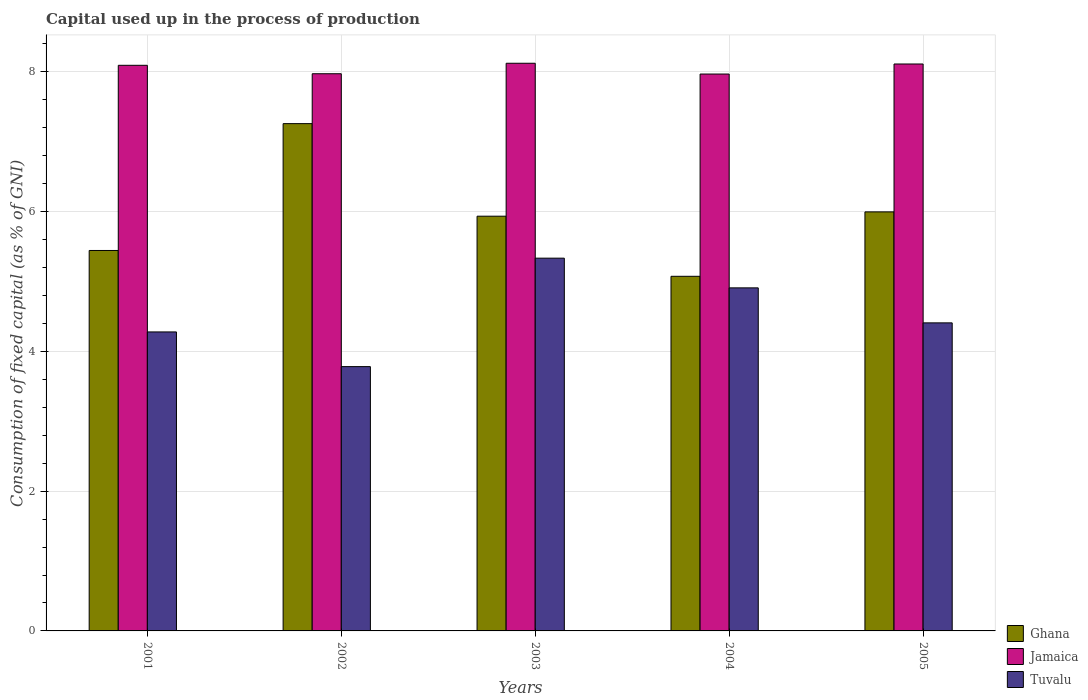How many different coloured bars are there?
Your answer should be compact. 3. Are the number of bars on each tick of the X-axis equal?
Your answer should be very brief. Yes. How many bars are there on the 1st tick from the right?
Provide a succinct answer. 3. What is the label of the 4th group of bars from the left?
Offer a very short reply. 2004. In how many cases, is the number of bars for a given year not equal to the number of legend labels?
Keep it short and to the point. 0. What is the capital used up in the process of production in Jamaica in 2001?
Make the answer very short. 8.09. Across all years, what is the maximum capital used up in the process of production in Tuvalu?
Make the answer very short. 5.33. Across all years, what is the minimum capital used up in the process of production in Tuvalu?
Your answer should be very brief. 3.78. In which year was the capital used up in the process of production in Jamaica maximum?
Provide a succinct answer. 2003. In which year was the capital used up in the process of production in Tuvalu minimum?
Offer a very short reply. 2002. What is the total capital used up in the process of production in Jamaica in the graph?
Your response must be concise. 40.27. What is the difference between the capital used up in the process of production in Ghana in 2001 and that in 2005?
Provide a short and direct response. -0.55. What is the difference between the capital used up in the process of production in Jamaica in 2002 and the capital used up in the process of production in Ghana in 2004?
Ensure brevity in your answer.  2.9. What is the average capital used up in the process of production in Jamaica per year?
Your answer should be compact. 8.05. In the year 2003, what is the difference between the capital used up in the process of production in Ghana and capital used up in the process of production in Tuvalu?
Provide a short and direct response. 0.6. In how many years, is the capital used up in the process of production in Ghana greater than 2 %?
Keep it short and to the point. 5. What is the ratio of the capital used up in the process of production in Ghana in 2002 to that in 2004?
Ensure brevity in your answer.  1.43. Is the capital used up in the process of production in Tuvalu in 2002 less than that in 2005?
Offer a very short reply. Yes. What is the difference between the highest and the second highest capital used up in the process of production in Tuvalu?
Your answer should be very brief. 0.43. What is the difference between the highest and the lowest capital used up in the process of production in Tuvalu?
Give a very brief answer. 1.55. In how many years, is the capital used up in the process of production in Tuvalu greater than the average capital used up in the process of production in Tuvalu taken over all years?
Provide a succinct answer. 2. What does the 3rd bar from the left in 2002 represents?
Your answer should be very brief. Tuvalu. What does the 2nd bar from the right in 2002 represents?
Provide a short and direct response. Jamaica. Is it the case that in every year, the sum of the capital used up in the process of production in Jamaica and capital used up in the process of production in Ghana is greater than the capital used up in the process of production in Tuvalu?
Your response must be concise. Yes. How many bars are there?
Offer a very short reply. 15. Are all the bars in the graph horizontal?
Your answer should be very brief. No. How many years are there in the graph?
Provide a succinct answer. 5. Does the graph contain any zero values?
Provide a short and direct response. No. Where does the legend appear in the graph?
Your answer should be very brief. Bottom right. How are the legend labels stacked?
Give a very brief answer. Vertical. What is the title of the graph?
Keep it short and to the point. Capital used up in the process of production. Does "Georgia" appear as one of the legend labels in the graph?
Make the answer very short. No. What is the label or title of the Y-axis?
Offer a terse response. Consumption of fixed capital (as % of GNI). What is the Consumption of fixed capital (as % of GNI) in Ghana in 2001?
Your answer should be compact. 5.44. What is the Consumption of fixed capital (as % of GNI) of Jamaica in 2001?
Give a very brief answer. 8.09. What is the Consumption of fixed capital (as % of GNI) of Tuvalu in 2001?
Offer a terse response. 4.28. What is the Consumption of fixed capital (as % of GNI) in Ghana in 2002?
Your response must be concise. 7.26. What is the Consumption of fixed capital (as % of GNI) of Jamaica in 2002?
Make the answer very short. 7.97. What is the Consumption of fixed capital (as % of GNI) in Tuvalu in 2002?
Provide a short and direct response. 3.78. What is the Consumption of fixed capital (as % of GNI) of Ghana in 2003?
Provide a short and direct response. 5.94. What is the Consumption of fixed capital (as % of GNI) in Jamaica in 2003?
Give a very brief answer. 8.12. What is the Consumption of fixed capital (as % of GNI) in Tuvalu in 2003?
Your response must be concise. 5.33. What is the Consumption of fixed capital (as % of GNI) of Ghana in 2004?
Provide a succinct answer. 5.07. What is the Consumption of fixed capital (as % of GNI) in Jamaica in 2004?
Keep it short and to the point. 7.97. What is the Consumption of fixed capital (as % of GNI) of Tuvalu in 2004?
Provide a short and direct response. 4.91. What is the Consumption of fixed capital (as % of GNI) in Ghana in 2005?
Provide a succinct answer. 6. What is the Consumption of fixed capital (as % of GNI) in Jamaica in 2005?
Make the answer very short. 8.11. What is the Consumption of fixed capital (as % of GNI) in Tuvalu in 2005?
Your answer should be very brief. 4.41. Across all years, what is the maximum Consumption of fixed capital (as % of GNI) in Ghana?
Your answer should be compact. 7.26. Across all years, what is the maximum Consumption of fixed capital (as % of GNI) in Jamaica?
Offer a terse response. 8.12. Across all years, what is the maximum Consumption of fixed capital (as % of GNI) of Tuvalu?
Ensure brevity in your answer.  5.33. Across all years, what is the minimum Consumption of fixed capital (as % of GNI) in Ghana?
Your answer should be very brief. 5.07. Across all years, what is the minimum Consumption of fixed capital (as % of GNI) in Jamaica?
Offer a very short reply. 7.97. Across all years, what is the minimum Consumption of fixed capital (as % of GNI) in Tuvalu?
Your answer should be compact. 3.78. What is the total Consumption of fixed capital (as % of GNI) of Ghana in the graph?
Your answer should be compact. 29.71. What is the total Consumption of fixed capital (as % of GNI) of Jamaica in the graph?
Your response must be concise. 40.27. What is the total Consumption of fixed capital (as % of GNI) of Tuvalu in the graph?
Your answer should be compact. 22.71. What is the difference between the Consumption of fixed capital (as % of GNI) of Ghana in 2001 and that in 2002?
Ensure brevity in your answer.  -1.82. What is the difference between the Consumption of fixed capital (as % of GNI) in Jamaica in 2001 and that in 2002?
Offer a very short reply. 0.12. What is the difference between the Consumption of fixed capital (as % of GNI) of Tuvalu in 2001 and that in 2002?
Provide a succinct answer. 0.5. What is the difference between the Consumption of fixed capital (as % of GNI) of Ghana in 2001 and that in 2003?
Keep it short and to the point. -0.49. What is the difference between the Consumption of fixed capital (as % of GNI) of Jamaica in 2001 and that in 2003?
Ensure brevity in your answer.  -0.03. What is the difference between the Consumption of fixed capital (as % of GNI) in Tuvalu in 2001 and that in 2003?
Offer a terse response. -1.06. What is the difference between the Consumption of fixed capital (as % of GNI) of Ghana in 2001 and that in 2004?
Provide a succinct answer. 0.37. What is the difference between the Consumption of fixed capital (as % of GNI) in Jamaica in 2001 and that in 2004?
Your response must be concise. 0.12. What is the difference between the Consumption of fixed capital (as % of GNI) in Tuvalu in 2001 and that in 2004?
Provide a short and direct response. -0.63. What is the difference between the Consumption of fixed capital (as % of GNI) of Ghana in 2001 and that in 2005?
Give a very brief answer. -0.55. What is the difference between the Consumption of fixed capital (as % of GNI) in Jamaica in 2001 and that in 2005?
Make the answer very short. -0.02. What is the difference between the Consumption of fixed capital (as % of GNI) of Tuvalu in 2001 and that in 2005?
Offer a very short reply. -0.13. What is the difference between the Consumption of fixed capital (as % of GNI) in Ghana in 2002 and that in 2003?
Your response must be concise. 1.32. What is the difference between the Consumption of fixed capital (as % of GNI) of Tuvalu in 2002 and that in 2003?
Provide a succinct answer. -1.55. What is the difference between the Consumption of fixed capital (as % of GNI) in Ghana in 2002 and that in 2004?
Keep it short and to the point. 2.18. What is the difference between the Consumption of fixed capital (as % of GNI) of Jamaica in 2002 and that in 2004?
Offer a very short reply. 0. What is the difference between the Consumption of fixed capital (as % of GNI) in Tuvalu in 2002 and that in 2004?
Keep it short and to the point. -1.13. What is the difference between the Consumption of fixed capital (as % of GNI) of Ghana in 2002 and that in 2005?
Provide a succinct answer. 1.26. What is the difference between the Consumption of fixed capital (as % of GNI) of Jamaica in 2002 and that in 2005?
Your answer should be very brief. -0.14. What is the difference between the Consumption of fixed capital (as % of GNI) in Tuvalu in 2002 and that in 2005?
Your answer should be very brief. -0.63. What is the difference between the Consumption of fixed capital (as % of GNI) of Ghana in 2003 and that in 2004?
Offer a terse response. 0.86. What is the difference between the Consumption of fixed capital (as % of GNI) in Jamaica in 2003 and that in 2004?
Offer a very short reply. 0.15. What is the difference between the Consumption of fixed capital (as % of GNI) in Tuvalu in 2003 and that in 2004?
Make the answer very short. 0.42. What is the difference between the Consumption of fixed capital (as % of GNI) of Ghana in 2003 and that in 2005?
Make the answer very short. -0.06. What is the difference between the Consumption of fixed capital (as % of GNI) in Jamaica in 2003 and that in 2005?
Provide a short and direct response. 0.01. What is the difference between the Consumption of fixed capital (as % of GNI) of Tuvalu in 2003 and that in 2005?
Offer a terse response. 0.93. What is the difference between the Consumption of fixed capital (as % of GNI) in Ghana in 2004 and that in 2005?
Provide a short and direct response. -0.92. What is the difference between the Consumption of fixed capital (as % of GNI) in Jamaica in 2004 and that in 2005?
Keep it short and to the point. -0.14. What is the difference between the Consumption of fixed capital (as % of GNI) in Tuvalu in 2004 and that in 2005?
Keep it short and to the point. 0.5. What is the difference between the Consumption of fixed capital (as % of GNI) of Ghana in 2001 and the Consumption of fixed capital (as % of GNI) of Jamaica in 2002?
Make the answer very short. -2.53. What is the difference between the Consumption of fixed capital (as % of GNI) in Ghana in 2001 and the Consumption of fixed capital (as % of GNI) in Tuvalu in 2002?
Offer a very short reply. 1.66. What is the difference between the Consumption of fixed capital (as % of GNI) in Jamaica in 2001 and the Consumption of fixed capital (as % of GNI) in Tuvalu in 2002?
Offer a terse response. 4.31. What is the difference between the Consumption of fixed capital (as % of GNI) in Ghana in 2001 and the Consumption of fixed capital (as % of GNI) in Jamaica in 2003?
Provide a succinct answer. -2.68. What is the difference between the Consumption of fixed capital (as % of GNI) of Ghana in 2001 and the Consumption of fixed capital (as % of GNI) of Tuvalu in 2003?
Give a very brief answer. 0.11. What is the difference between the Consumption of fixed capital (as % of GNI) of Jamaica in 2001 and the Consumption of fixed capital (as % of GNI) of Tuvalu in 2003?
Make the answer very short. 2.76. What is the difference between the Consumption of fixed capital (as % of GNI) in Ghana in 2001 and the Consumption of fixed capital (as % of GNI) in Jamaica in 2004?
Your answer should be compact. -2.52. What is the difference between the Consumption of fixed capital (as % of GNI) in Ghana in 2001 and the Consumption of fixed capital (as % of GNI) in Tuvalu in 2004?
Your answer should be very brief. 0.54. What is the difference between the Consumption of fixed capital (as % of GNI) in Jamaica in 2001 and the Consumption of fixed capital (as % of GNI) in Tuvalu in 2004?
Ensure brevity in your answer.  3.18. What is the difference between the Consumption of fixed capital (as % of GNI) in Ghana in 2001 and the Consumption of fixed capital (as % of GNI) in Jamaica in 2005?
Keep it short and to the point. -2.67. What is the difference between the Consumption of fixed capital (as % of GNI) of Ghana in 2001 and the Consumption of fixed capital (as % of GNI) of Tuvalu in 2005?
Provide a short and direct response. 1.04. What is the difference between the Consumption of fixed capital (as % of GNI) in Jamaica in 2001 and the Consumption of fixed capital (as % of GNI) in Tuvalu in 2005?
Provide a short and direct response. 3.69. What is the difference between the Consumption of fixed capital (as % of GNI) in Ghana in 2002 and the Consumption of fixed capital (as % of GNI) in Jamaica in 2003?
Keep it short and to the point. -0.86. What is the difference between the Consumption of fixed capital (as % of GNI) of Ghana in 2002 and the Consumption of fixed capital (as % of GNI) of Tuvalu in 2003?
Provide a short and direct response. 1.93. What is the difference between the Consumption of fixed capital (as % of GNI) of Jamaica in 2002 and the Consumption of fixed capital (as % of GNI) of Tuvalu in 2003?
Ensure brevity in your answer.  2.64. What is the difference between the Consumption of fixed capital (as % of GNI) in Ghana in 2002 and the Consumption of fixed capital (as % of GNI) in Jamaica in 2004?
Keep it short and to the point. -0.71. What is the difference between the Consumption of fixed capital (as % of GNI) of Ghana in 2002 and the Consumption of fixed capital (as % of GNI) of Tuvalu in 2004?
Make the answer very short. 2.35. What is the difference between the Consumption of fixed capital (as % of GNI) in Jamaica in 2002 and the Consumption of fixed capital (as % of GNI) in Tuvalu in 2004?
Provide a succinct answer. 3.06. What is the difference between the Consumption of fixed capital (as % of GNI) in Ghana in 2002 and the Consumption of fixed capital (as % of GNI) in Jamaica in 2005?
Make the answer very short. -0.85. What is the difference between the Consumption of fixed capital (as % of GNI) of Ghana in 2002 and the Consumption of fixed capital (as % of GNI) of Tuvalu in 2005?
Your answer should be compact. 2.85. What is the difference between the Consumption of fixed capital (as % of GNI) of Jamaica in 2002 and the Consumption of fixed capital (as % of GNI) of Tuvalu in 2005?
Make the answer very short. 3.57. What is the difference between the Consumption of fixed capital (as % of GNI) of Ghana in 2003 and the Consumption of fixed capital (as % of GNI) of Jamaica in 2004?
Keep it short and to the point. -2.03. What is the difference between the Consumption of fixed capital (as % of GNI) in Ghana in 2003 and the Consumption of fixed capital (as % of GNI) in Tuvalu in 2004?
Your answer should be very brief. 1.03. What is the difference between the Consumption of fixed capital (as % of GNI) in Jamaica in 2003 and the Consumption of fixed capital (as % of GNI) in Tuvalu in 2004?
Offer a terse response. 3.21. What is the difference between the Consumption of fixed capital (as % of GNI) in Ghana in 2003 and the Consumption of fixed capital (as % of GNI) in Jamaica in 2005?
Give a very brief answer. -2.18. What is the difference between the Consumption of fixed capital (as % of GNI) of Ghana in 2003 and the Consumption of fixed capital (as % of GNI) of Tuvalu in 2005?
Provide a succinct answer. 1.53. What is the difference between the Consumption of fixed capital (as % of GNI) in Jamaica in 2003 and the Consumption of fixed capital (as % of GNI) in Tuvalu in 2005?
Offer a very short reply. 3.72. What is the difference between the Consumption of fixed capital (as % of GNI) in Ghana in 2004 and the Consumption of fixed capital (as % of GNI) in Jamaica in 2005?
Offer a very short reply. -3.04. What is the difference between the Consumption of fixed capital (as % of GNI) in Ghana in 2004 and the Consumption of fixed capital (as % of GNI) in Tuvalu in 2005?
Offer a terse response. 0.67. What is the difference between the Consumption of fixed capital (as % of GNI) in Jamaica in 2004 and the Consumption of fixed capital (as % of GNI) in Tuvalu in 2005?
Offer a terse response. 3.56. What is the average Consumption of fixed capital (as % of GNI) in Ghana per year?
Offer a terse response. 5.94. What is the average Consumption of fixed capital (as % of GNI) of Jamaica per year?
Make the answer very short. 8.05. What is the average Consumption of fixed capital (as % of GNI) of Tuvalu per year?
Offer a very short reply. 4.54. In the year 2001, what is the difference between the Consumption of fixed capital (as % of GNI) of Ghana and Consumption of fixed capital (as % of GNI) of Jamaica?
Give a very brief answer. -2.65. In the year 2001, what is the difference between the Consumption of fixed capital (as % of GNI) of Ghana and Consumption of fixed capital (as % of GNI) of Tuvalu?
Provide a succinct answer. 1.17. In the year 2001, what is the difference between the Consumption of fixed capital (as % of GNI) of Jamaica and Consumption of fixed capital (as % of GNI) of Tuvalu?
Your response must be concise. 3.82. In the year 2002, what is the difference between the Consumption of fixed capital (as % of GNI) in Ghana and Consumption of fixed capital (as % of GNI) in Jamaica?
Your answer should be very brief. -0.71. In the year 2002, what is the difference between the Consumption of fixed capital (as % of GNI) in Ghana and Consumption of fixed capital (as % of GNI) in Tuvalu?
Make the answer very short. 3.48. In the year 2002, what is the difference between the Consumption of fixed capital (as % of GNI) of Jamaica and Consumption of fixed capital (as % of GNI) of Tuvalu?
Offer a very short reply. 4.19. In the year 2003, what is the difference between the Consumption of fixed capital (as % of GNI) in Ghana and Consumption of fixed capital (as % of GNI) in Jamaica?
Offer a very short reply. -2.19. In the year 2003, what is the difference between the Consumption of fixed capital (as % of GNI) in Ghana and Consumption of fixed capital (as % of GNI) in Tuvalu?
Give a very brief answer. 0.6. In the year 2003, what is the difference between the Consumption of fixed capital (as % of GNI) in Jamaica and Consumption of fixed capital (as % of GNI) in Tuvalu?
Your response must be concise. 2.79. In the year 2004, what is the difference between the Consumption of fixed capital (as % of GNI) in Ghana and Consumption of fixed capital (as % of GNI) in Jamaica?
Offer a very short reply. -2.89. In the year 2004, what is the difference between the Consumption of fixed capital (as % of GNI) of Ghana and Consumption of fixed capital (as % of GNI) of Tuvalu?
Your response must be concise. 0.17. In the year 2004, what is the difference between the Consumption of fixed capital (as % of GNI) in Jamaica and Consumption of fixed capital (as % of GNI) in Tuvalu?
Your answer should be compact. 3.06. In the year 2005, what is the difference between the Consumption of fixed capital (as % of GNI) of Ghana and Consumption of fixed capital (as % of GNI) of Jamaica?
Provide a short and direct response. -2.12. In the year 2005, what is the difference between the Consumption of fixed capital (as % of GNI) in Ghana and Consumption of fixed capital (as % of GNI) in Tuvalu?
Your response must be concise. 1.59. In the year 2005, what is the difference between the Consumption of fixed capital (as % of GNI) in Jamaica and Consumption of fixed capital (as % of GNI) in Tuvalu?
Offer a very short reply. 3.7. What is the ratio of the Consumption of fixed capital (as % of GNI) of Ghana in 2001 to that in 2002?
Offer a very short reply. 0.75. What is the ratio of the Consumption of fixed capital (as % of GNI) in Jamaica in 2001 to that in 2002?
Ensure brevity in your answer.  1.02. What is the ratio of the Consumption of fixed capital (as % of GNI) of Tuvalu in 2001 to that in 2002?
Offer a very short reply. 1.13. What is the ratio of the Consumption of fixed capital (as % of GNI) in Ghana in 2001 to that in 2003?
Your answer should be compact. 0.92. What is the ratio of the Consumption of fixed capital (as % of GNI) in Tuvalu in 2001 to that in 2003?
Give a very brief answer. 0.8. What is the ratio of the Consumption of fixed capital (as % of GNI) of Ghana in 2001 to that in 2004?
Offer a terse response. 1.07. What is the ratio of the Consumption of fixed capital (as % of GNI) in Jamaica in 2001 to that in 2004?
Make the answer very short. 1.02. What is the ratio of the Consumption of fixed capital (as % of GNI) of Tuvalu in 2001 to that in 2004?
Your answer should be very brief. 0.87. What is the ratio of the Consumption of fixed capital (as % of GNI) of Ghana in 2001 to that in 2005?
Ensure brevity in your answer.  0.91. What is the ratio of the Consumption of fixed capital (as % of GNI) in Tuvalu in 2001 to that in 2005?
Offer a terse response. 0.97. What is the ratio of the Consumption of fixed capital (as % of GNI) in Ghana in 2002 to that in 2003?
Provide a succinct answer. 1.22. What is the ratio of the Consumption of fixed capital (as % of GNI) of Jamaica in 2002 to that in 2003?
Provide a short and direct response. 0.98. What is the ratio of the Consumption of fixed capital (as % of GNI) in Tuvalu in 2002 to that in 2003?
Ensure brevity in your answer.  0.71. What is the ratio of the Consumption of fixed capital (as % of GNI) of Ghana in 2002 to that in 2004?
Give a very brief answer. 1.43. What is the ratio of the Consumption of fixed capital (as % of GNI) in Tuvalu in 2002 to that in 2004?
Your response must be concise. 0.77. What is the ratio of the Consumption of fixed capital (as % of GNI) in Ghana in 2002 to that in 2005?
Your response must be concise. 1.21. What is the ratio of the Consumption of fixed capital (as % of GNI) in Jamaica in 2002 to that in 2005?
Provide a short and direct response. 0.98. What is the ratio of the Consumption of fixed capital (as % of GNI) of Tuvalu in 2002 to that in 2005?
Give a very brief answer. 0.86. What is the ratio of the Consumption of fixed capital (as % of GNI) of Ghana in 2003 to that in 2004?
Give a very brief answer. 1.17. What is the ratio of the Consumption of fixed capital (as % of GNI) in Jamaica in 2003 to that in 2004?
Your response must be concise. 1.02. What is the ratio of the Consumption of fixed capital (as % of GNI) of Tuvalu in 2003 to that in 2004?
Offer a very short reply. 1.09. What is the ratio of the Consumption of fixed capital (as % of GNI) in Tuvalu in 2003 to that in 2005?
Make the answer very short. 1.21. What is the ratio of the Consumption of fixed capital (as % of GNI) in Ghana in 2004 to that in 2005?
Offer a very short reply. 0.85. What is the ratio of the Consumption of fixed capital (as % of GNI) of Jamaica in 2004 to that in 2005?
Offer a very short reply. 0.98. What is the ratio of the Consumption of fixed capital (as % of GNI) of Tuvalu in 2004 to that in 2005?
Provide a succinct answer. 1.11. What is the difference between the highest and the second highest Consumption of fixed capital (as % of GNI) in Ghana?
Give a very brief answer. 1.26. What is the difference between the highest and the second highest Consumption of fixed capital (as % of GNI) in Jamaica?
Your answer should be very brief. 0.01. What is the difference between the highest and the second highest Consumption of fixed capital (as % of GNI) in Tuvalu?
Keep it short and to the point. 0.42. What is the difference between the highest and the lowest Consumption of fixed capital (as % of GNI) in Ghana?
Make the answer very short. 2.18. What is the difference between the highest and the lowest Consumption of fixed capital (as % of GNI) of Jamaica?
Provide a succinct answer. 0.15. What is the difference between the highest and the lowest Consumption of fixed capital (as % of GNI) of Tuvalu?
Your answer should be very brief. 1.55. 